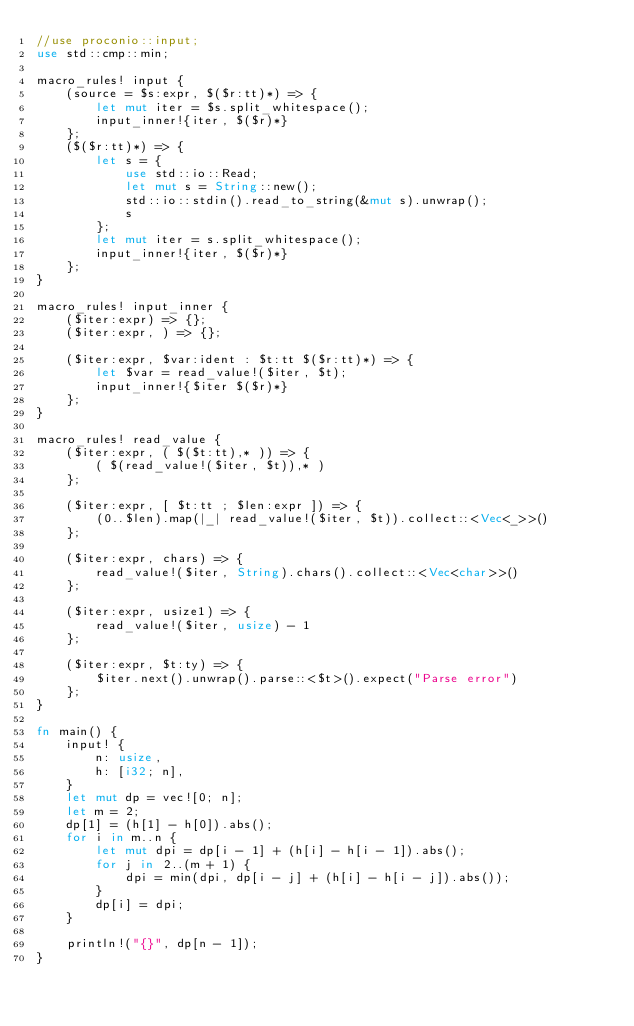Convert code to text. <code><loc_0><loc_0><loc_500><loc_500><_Rust_>//use proconio::input;
use std::cmp::min;

macro_rules! input {
    (source = $s:expr, $($r:tt)*) => {
        let mut iter = $s.split_whitespace();
        input_inner!{iter, $($r)*}
    };
    ($($r:tt)*) => {
        let s = {
            use std::io::Read;
            let mut s = String::new();
            std::io::stdin().read_to_string(&mut s).unwrap();
            s
        };
        let mut iter = s.split_whitespace();
        input_inner!{iter, $($r)*}
    };
}

macro_rules! input_inner {
    ($iter:expr) => {};
    ($iter:expr, ) => {};

    ($iter:expr, $var:ident : $t:tt $($r:tt)*) => {
        let $var = read_value!($iter, $t);
        input_inner!{$iter $($r)*}
    };
}

macro_rules! read_value {
    ($iter:expr, ( $($t:tt),* )) => {
        ( $(read_value!($iter, $t)),* )
    };

    ($iter:expr, [ $t:tt ; $len:expr ]) => {
        (0..$len).map(|_| read_value!($iter, $t)).collect::<Vec<_>>()
    };

    ($iter:expr, chars) => {
        read_value!($iter, String).chars().collect::<Vec<char>>()
    };

    ($iter:expr, usize1) => {
        read_value!($iter, usize) - 1
    };

    ($iter:expr, $t:ty) => {
        $iter.next().unwrap().parse::<$t>().expect("Parse error")
    };
}

fn main() {
    input! {
        n: usize,
        h: [i32; n],
    }
    let mut dp = vec![0; n];
    let m = 2;
    dp[1] = (h[1] - h[0]).abs();
    for i in m..n {
        let mut dpi = dp[i - 1] + (h[i] - h[i - 1]).abs();
        for j in 2..(m + 1) {
            dpi = min(dpi, dp[i - j] + (h[i] - h[i - j]).abs());
        }
        dp[i] = dpi;
    }

    println!("{}", dp[n - 1]);
}
</code> 